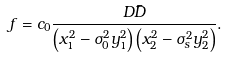Convert formula to latex. <formula><loc_0><loc_0><loc_500><loc_500>f = c _ { 0 } \frac { D \bar { D } } { \left ( x _ { 1 } ^ { 2 } - \sigma _ { 0 } ^ { 2 } y _ { 1 } ^ { 2 } \right ) \left ( x _ { 2 } ^ { 2 } - \sigma _ { s } ^ { 2 } y _ { 2 } ^ { 2 } \right ) } .</formula> 